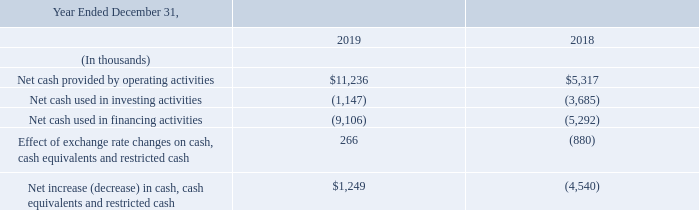Liquidity and Capital Resources
As of December 31, 2019, we had $19.5 million in cash and cash equivalents, of which $14.8 million was held outside the U.S. in certain of our foreign operations. If these assets are distributed to the U.S., we may be subject to additional U.S. taxes in certain circumstances. We have not provided for any repatriation taxes and currently have the intent to leave such cash and cash equivalents in the foreign countries. Cash and cash equivalents increased from $18.0 million as of December 31, 2018 primarily as a result of cash provided by operating activities, offset partially by cash used for repurchases of our common stock and our equity investment in WeekenGO. We expect that cash on hand will be sufficient to provide for working capital needs for at least the next twelve months.
Net cash provided by operating activities is net income adjusted for certain non-cash items and changes in assets and liabilities. Net cash provided by operating activities was $11.2 million for 2019, which consisted of net income of $4.2 million, adjustments for non-cash items of $3.8 million and a $3.2 million increase in cash from changes in operating assets and liabilities. Adjustments for non-cash items primarily consisted of a $1.3 million of depreciation and amortization expense on property and equipment, a $993,000 of stock-based compensation expense and $821,000 for our share of WeekenGO losses, amortization of basis differences and currency translation adjustment. The increase in cash from changes in operating assets and liabilities primarily consisted of a $3.1 million increase in accounts payable.
Net cash provided by operating activities was $5.3 million for 2018, which consisted of a net income of $4.7 million, adjustments for non-cash items of $2.5 million, offset partially a $1.9 million decrease in cash from changes in operating assets and liabilities. Adjustments for non-cash items primarily consisted of a $1.8 million of depreciation and amortization expense on property and equipment and a $915,000 of stock-based compensation expense. The decrease in cash from changes in operating assets and liabilities primarily consisted of a $1.5 million increase in accounts receivable.
Cash paid for income taxes, net of refunds received in 2019 and 2018, was $4.7 million and $4.3 million, respectively.
Net cash used in investing activities for 2019 and 2018 was $1.1 million and $3.7 million, respectively. The cash used in investing activities in 2019 was primarily due to $673,000 investment in WeekenGO and $474,000 in purchases of property and equipment. The cash used in investing activities in 2018 was primarily due to $3.1 million investment in WeekenGO and $752,000 in purchases of property and equipment, offset partially by $150,000 proceeds from sale of property and equipment.
Net cash used in financing activities for 2019 and 2018 was $9.1 million and $5.3 million, respectively. Net cash used in financing activities for the year ended December 31, 2019 was primarily due to $10.8 million used in repurchases of our common stock, offset partially by $1.7 million of proceeds from the issuance of common stock, net of tax paid for the net share settlement. Net cash used in financing activities for the year ended December 31, 2018 was primarily due to $5.3 million cash used in repurchases of our common stock.
What is the net cash provided by operating activities in 2019 and 2018 respectively?
Answer scale should be: thousand. $11,236, $5,317. What is the net cash used in investing activities in 2019 and 2018 respectively?
Answer scale should be: thousand. 1,147, 3,685. What is the net cash used in financing activities in 2019 and 2018 respectively?
Answer scale should be: thousand. 9,106, 5,292. What is the change in net cash provided by operating activities between 2019 and 2018?
Answer scale should be: thousand. 11,236-5,317
Answer: 5919. What is the change in cash paid for income taxes, net of refunds received between 2019 and 2018?
Answer scale should be: million. 4.7-4.3
Answer: 0.4. Which year has a higher net cash provided by operating activities? Look at COL 3 and COL 4 and compare the values in row 4
Answer: 2019. 